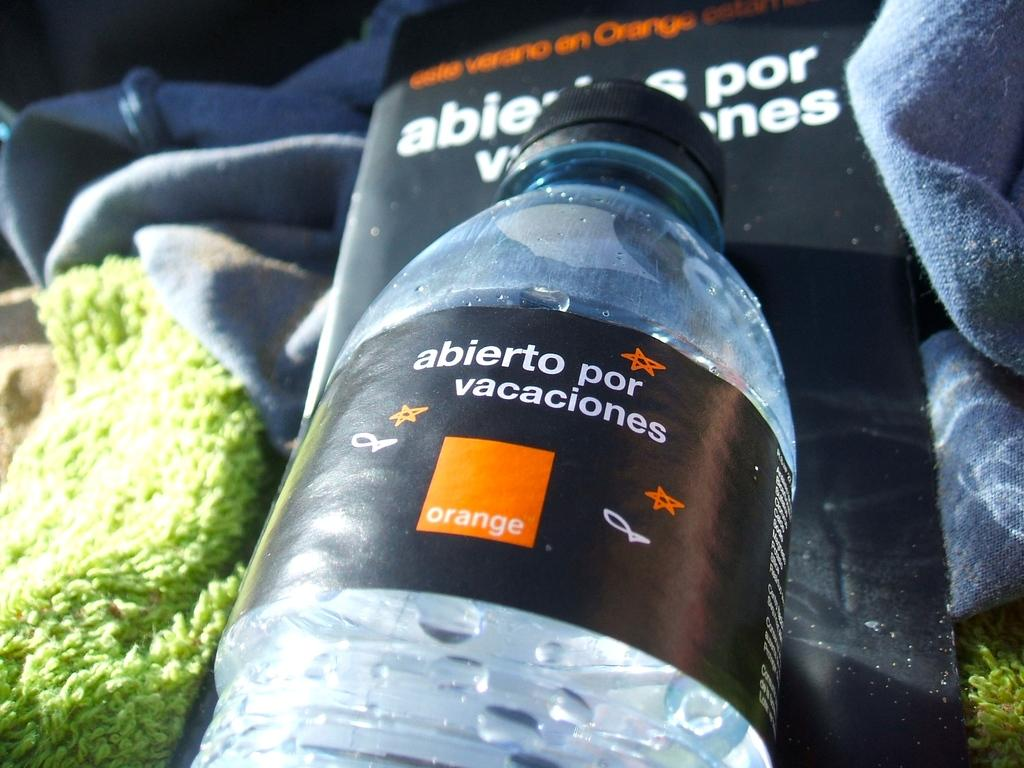What is the main object in the middle of the image? There is a bottle in the middle of the image. What can be found on the bottle? The bottle has a label with written text on it. What can be seen in the background of the image? There is a towel and a poster in the background of the image. How does the thumb help the jellyfish in the image? There is no thumb or jellyfish present in the image. 